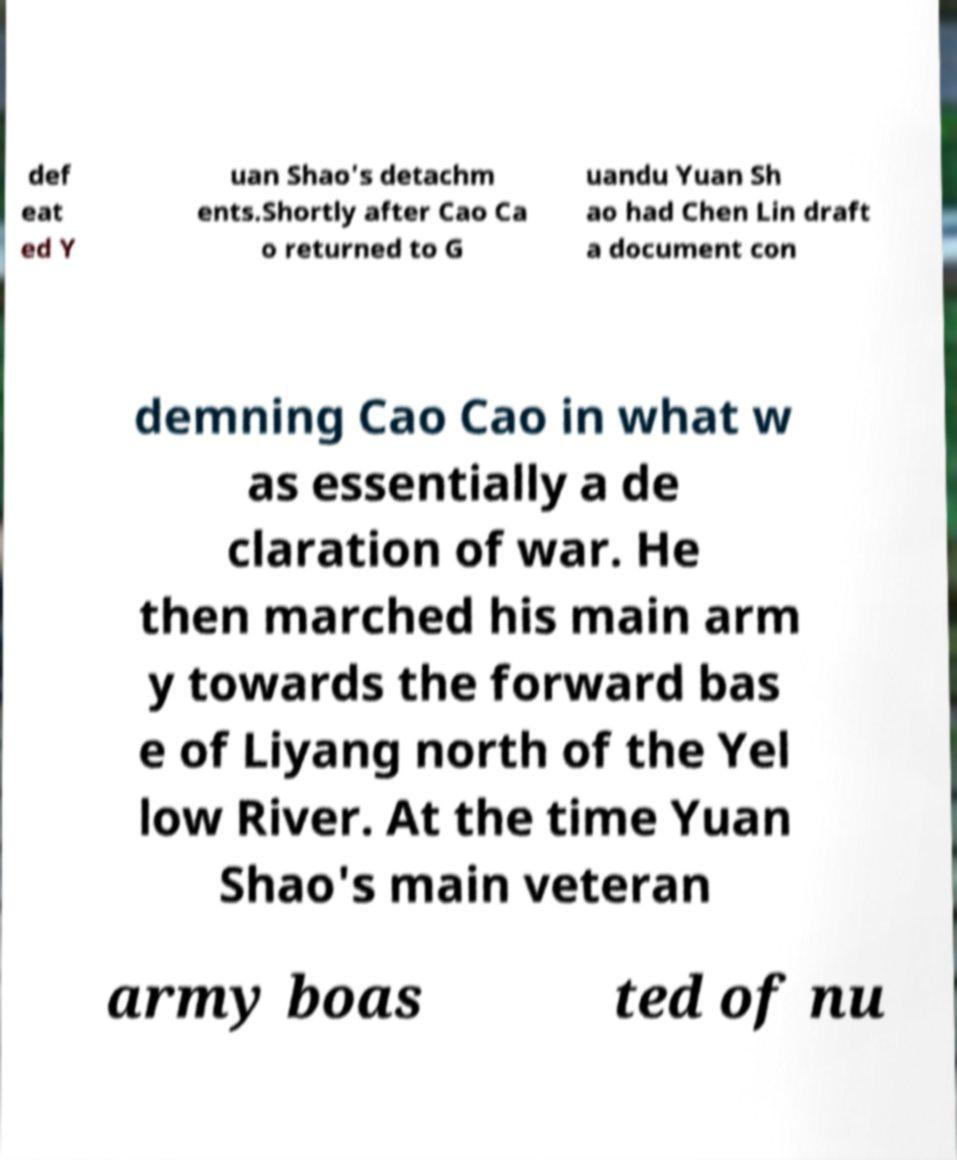There's text embedded in this image that I need extracted. Can you transcribe it verbatim? def eat ed Y uan Shao's detachm ents.Shortly after Cao Ca o returned to G uandu Yuan Sh ao had Chen Lin draft a document con demning Cao Cao in what w as essentially a de claration of war. He then marched his main arm y towards the forward bas e of Liyang north of the Yel low River. At the time Yuan Shao's main veteran army boas ted of nu 